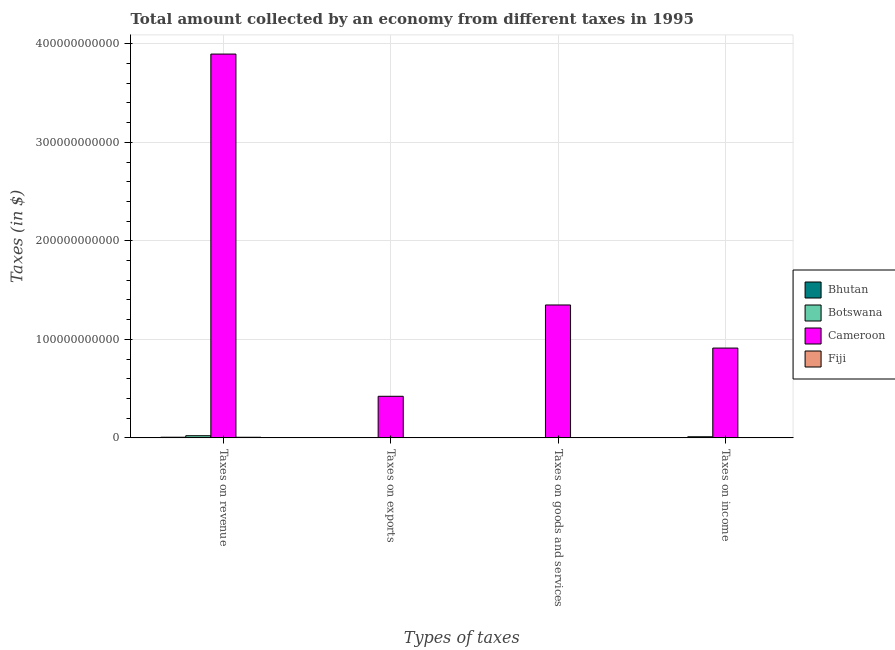How many groups of bars are there?
Give a very brief answer. 4. Are the number of bars per tick equal to the number of legend labels?
Keep it short and to the point. Yes. How many bars are there on the 3rd tick from the right?
Your answer should be very brief. 4. What is the label of the 4th group of bars from the left?
Keep it short and to the point. Taxes on income. What is the amount collected as tax on income in Bhutan?
Your response must be concise. 2.64e+08. Across all countries, what is the maximum amount collected as tax on goods?
Your answer should be compact. 1.35e+11. Across all countries, what is the minimum amount collected as tax on income?
Make the answer very short. 2.25e+08. In which country was the amount collected as tax on income maximum?
Give a very brief answer. Cameroon. In which country was the amount collected as tax on goods minimum?
Provide a short and direct response. Fiji. What is the total amount collected as tax on income in the graph?
Provide a short and direct response. 9.28e+1. What is the difference between the amount collected as tax on exports in Botswana and that in Fiji?
Make the answer very short. -1.09e+07. What is the difference between the amount collected as tax on revenue in Cameroon and the amount collected as tax on income in Bhutan?
Your response must be concise. 3.89e+11. What is the average amount collected as tax on revenue per country?
Give a very brief answer. 9.83e+1. What is the difference between the amount collected as tax on income and amount collected as tax on exports in Botswana?
Ensure brevity in your answer.  1.13e+09. In how many countries, is the amount collected as tax on income greater than 200000000000 $?
Ensure brevity in your answer.  0. What is the ratio of the amount collected as tax on exports in Bhutan to that in Cameroon?
Your answer should be very brief. 0. What is the difference between the highest and the second highest amount collected as tax on revenue?
Make the answer very short. 3.87e+11. What is the difference between the highest and the lowest amount collected as tax on exports?
Your answer should be compact. 4.22e+1. In how many countries, is the amount collected as tax on income greater than the average amount collected as tax on income taken over all countries?
Your response must be concise. 1. Is the sum of the amount collected as tax on exports in Botswana and Fiji greater than the maximum amount collected as tax on income across all countries?
Make the answer very short. No. Is it the case that in every country, the sum of the amount collected as tax on revenue and amount collected as tax on income is greater than the sum of amount collected as tax on goods and amount collected as tax on exports?
Keep it short and to the point. No. What does the 3rd bar from the left in Taxes on income represents?
Your answer should be compact. Cameroon. What does the 2nd bar from the right in Taxes on exports represents?
Your answer should be very brief. Cameroon. What is the difference between two consecutive major ticks on the Y-axis?
Offer a terse response. 1.00e+11. How many legend labels are there?
Give a very brief answer. 4. How are the legend labels stacked?
Offer a terse response. Vertical. What is the title of the graph?
Offer a very short reply. Total amount collected by an economy from different taxes in 1995. Does "Latvia" appear as one of the legend labels in the graph?
Your answer should be compact. No. What is the label or title of the X-axis?
Make the answer very short. Types of taxes. What is the label or title of the Y-axis?
Provide a succinct answer. Taxes (in $). What is the Taxes (in $) of Bhutan in Taxes on revenue?
Provide a succinct answer. 6.50e+08. What is the Taxes (in $) in Botswana in Taxes on revenue?
Provide a succinct answer. 2.20e+09. What is the Taxes (in $) of Cameroon in Taxes on revenue?
Make the answer very short. 3.90e+11. What is the Taxes (in $) in Fiji in Taxes on revenue?
Your answer should be compact. 6.15e+08. What is the Taxes (in $) in Bhutan in Taxes on exports?
Provide a short and direct response. 1.14e+07. What is the Taxes (in $) of Botswana in Taxes on exports?
Ensure brevity in your answer.  5.00e+05. What is the Taxes (in $) in Cameroon in Taxes on exports?
Provide a short and direct response. 4.22e+1. What is the Taxes (in $) of Fiji in Taxes on exports?
Give a very brief answer. 1.14e+07. What is the Taxes (in $) in Bhutan in Taxes on goods and services?
Provide a succinct answer. 3.39e+08. What is the Taxes (in $) of Botswana in Taxes on goods and services?
Provide a succinct answer. 2.38e+08. What is the Taxes (in $) in Cameroon in Taxes on goods and services?
Provide a succinct answer. 1.35e+11. What is the Taxes (in $) of Fiji in Taxes on goods and services?
Offer a terse response. 2.23e+08. What is the Taxes (in $) in Bhutan in Taxes on income?
Keep it short and to the point. 2.64e+08. What is the Taxes (in $) of Botswana in Taxes on income?
Offer a very short reply. 1.13e+09. What is the Taxes (in $) in Cameroon in Taxes on income?
Make the answer very short. 9.12e+1. What is the Taxes (in $) of Fiji in Taxes on income?
Your answer should be very brief. 2.25e+08. Across all Types of taxes, what is the maximum Taxes (in $) of Bhutan?
Keep it short and to the point. 6.50e+08. Across all Types of taxes, what is the maximum Taxes (in $) of Botswana?
Your answer should be compact. 2.20e+09. Across all Types of taxes, what is the maximum Taxes (in $) of Cameroon?
Make the answer very short. 3.90e+11. Across all Types of taxes, what is the maximum Taxes (in $) of Fiji?
Ensure brevity in your answer.  6.15e+08. Across all Types of taxes, what is the minimum Taxes (in $) in Bhutan?
Provide a short and direct response. 1.14e+07. Across all Types of taxes, what is the minimum Taxes (in $) of Botswana?
Ensure brevity in your answer.  5.00e+05. Across all Types of taxes, what is the minimum Taxes (in $) in Cameroon?
Keep it short and to the point. 4.22e+1. Across all Types of taxes, what is the minimum Taxes (in $) in Fiji?
Ensure brevity in your answer.  1.14e+07. What is the total Taxes (in $) of Bhutan in the graph?
Keep it short and to the point. 1.26e+09. What is the total Taxes (in $) of Botswana in the graph?
Your response must be concise. 3.56e+09. What is the total Taxes (in $) in Cameroon in the graph?
Make the answer very short. 6.58e+11. What is the total Taxes (in $) in Fiji in the graph?
Your answer should be compact. 1.07e+09. What is the difference between the Taxes (in $) of Bhutan in Taxes on revenue and that in Taxes on exports?
Your answer should be very brief. 6.38e+08. What is the difference between the Taxes (in $) of Botswana in Taxes on revenue and that in Taxes on exports?
Offer a very short reply. 2.20e+09. What is the difference between the Taxes (in $) in Cameroon in Taxes on revenue and that in Taxes on exports?
Make the answer very short. 3.47e+11. What is the difference between the Taxes (in $) of Fiji in Taxes on revenue and that in Taxes on exports?
Your answer should be compact. 6.04e+08. What is the difference between the Taxes (in $) in Bhutan in Taxes on revenue and that in Taxes on goods and services?
Offer a terse response. 3.11e+08. What is the difference between the Taxes (in $) in Botswana in Taxes on revenue and that in Taxes on goods and services?
Ensure brevity in your answer.  1.96e+09. What is the difference between the Taxes (in $) in Cameroon in Taxes on revenue and that in Taxes on goods and services?
Your answer should be compact. 2.55e+11. What is the difference between the Taxes (in $) of Fiji in Taxes on revenue and that in Taxes on goods and services?
Your answer should be compact. 3.93e+08. What is the difference between the Taxes (in $) in Bhutan in Taxes on revenue and that in Taxes on income?
Keep it short and to the point. 3.86e+08. What is the difference between the Taxes (in $) of Botswana in Taxes on revenue and that in Taxes on income?
Provide a short and direct response. 1.07e+09. What is the difference between the Taxes (in $) in Cameroon in Taxes on revenue and that in Taxes on income?
Ensure brevity in your answer.  2.98e+11. What is the difference between the Taxes (in $) in Fiji in Taxes on revenue and that in Taxes on income?
Provide a short and direct response. 3.90e+08. What is the difference between the Taxes (in $) in Bhutan in Taxes on exports and that in Taxes on goods and services?
Keep it short and to the point. -3.27e+08. What is the difference between the Taxes (in $) of Botswana in Taxes on exports and that in Taxes on goods and services?
Make the answer very short. -2.37e+08. What is the difference between the Taxes (in $) in Cameroon in Taxes on exports and that in Taxes on goods and services?
Offer a very short reply. -9.27e+1. What is the difference between the Taxes (in $) of Fiji in Taxes on exports and that in Taxes on goods and services?
Give a very brief answer. -2.11e+08. What is the difference between the Taxes (in $) of Bhutan in Taxes on exports and that in Taxes on income?
Offer a terse response. -2.52e+08. What is the difference between the Taxes (in $) in Botswana in Taxes on exports and that in Taxes on income?
Offer a very short reply. -1.13e+09. What is the difference between the Taxes (in $) of Cameroon in Taxes on exports and that in Taxes on income?
Ensure brevity in your answer.  -4.89e+1. What is the difference between the Taxes (in $) of Fiji in Taxes on exports and that in Taxes on income?
Offer a very short reply. -2.14e+08. What is the difference between the Taxes (in $) in Bhutan in Taxes on goods and services and that in Taxes on income?
Provide a short and direct response. 7.51e+07. What is the difference between the Taxes (in $) in Botswana in Taxes on goods and services and that in Taxes on income?
Your answer should be compact. -8.90e+08. What is the difference between the Taxes (in $) in Cameroon in Taxes on goods and services and that in Taxes on income?
Make the answer very short. 4.37e+1. What is the difference between the Taxes (in $) in Fiji in Taxes on goods and services and that in Taxes on income?
Your answer should be compact. -2.87e+06. What is the difference between the Taxes (in $) in Bhutan in Taxes on revenue and the Taxes (in $) in Botswana in Taxes on exports?
Your answer should be very brief. 6.49e+08. What is the difference between the Taxes (in $) of Bhutan in Taxes on revenue and the Taxes (in $) of Cameroon in Taxes on exports?
Make the answer very short. -4.16e+1. What is the difference between the Taxes (in $) of Bhutan in Taxes on revenue and the Taxes (in $) of Fiji in Taxes on exports?
Your response must be concise. 6.38e+08. What is the difference between the Taxes (in $) of Botswana in Taxes on revenue and the Taxes (in $) of Cameroon in Taxes on exports?
Your answer should be very brief. -4.00e+1. What is the difference between the Taxes (in $) of Botswana in Taxes on revenue and the Taxes (in $) of Fiji in Taxes on exports?
Your response must be concise. 2.19e+09. What is the difference between the Taxes (in $) of Cameroon in Taxes on revenue and the Taxes (in $) of Fiji in Taxes on exports?
Make the answer very short. 3.90e+11. What is the difference between the Taxes (in $) of Bhutan in Taxes on revenue and the Taxes (in $) of Botswana in Taxes on goods and services?
Provide a succinct answer. 4.12e+08. What is the difference between the Taxes (in $) in Bhutan in Taxes on revenue and the Taxes (in $) in Cameroon in Taxes on goods and services?
Offer a terse response. -1.34e+11. What is the difference between the Taxes (in $) of Bhutan in Taxes on revenue and the Taxes (in $) of Fiji in Taxes on goods and services?
Provide a succinct answer. 4.27e+08. What is the difference between the Taxes (in $) of Botswana in Taxes on revenue and the Taxes (in $) of Cameroon in Taxes on goods and services?
Make the answer very short. -1.33e+11. What is the difference between the Taxes (in $) in Botswana in Taxes on revenue and the Taxes (in $) in Fiji in Taxes on goods and services?
Offer a terse response. 1.98e+09. What is the difference between the Taxes (in $) of Cameroon in Taxes on revenue and the Taxes (in $) of Fiji in Taxes on goods and services?
Provide a succinct answer. 3.89e+11. What is the difference between the Taxes (in $) in Bhutan in Taxes on revenue and the Taxes (in $) in Botswana in Taxes on income?
Ensure brevity in your answer.  -4.77e+08. What is the difference between the Taxes (in $) of Bhutan in Taxes on revenue and the Taxes (in $) of Cameroon in Taxes on income?
Offer a very short reply. -9.05e+1. What is the difference between the Taxes (in $) in Bhutan in Taxes on revenue and the Taxes (in $) in Fiji in Taxes on income?
Your answer should be compact. 4.24e+08. What is the difference between the Taxes (in $) in Botswana in Taxes on revenue and the Taxes (in $) in Cameroon in Taxes on income?
Your answer should be very brief. -8.90e+1. What is the difference between the Taxes (in $) of Botswana in Taxes on revenue and the Taxes (in $) of Fiji in Taxes on income?
Give a very brief answer. 1.97e+09. What is the difference between the Taxes (in $) of Cameroon in Taxes on revenue and the Taxes (in $) of Fiji in Taxes on income?
Your answer should be compact. 3.89e+11. What is the difference between the Taxes (in $) in Bhutan in Taxes on exports and the Taxes (in $) in Botswana in Taxes on goods and services?
Provide a succinct answer. -2.26e+08. What is the difference between the Taxes (in $) in Bhutan in Taxes on exports and the Taxes (in $) in Cameroon in Taxes on goods and services?
Give a very brief answer. -1.35e+11. What is the difference between the Taxes (in $) of Bhutan in Taxes on exports and the Taxes (in $) of Fiji in Taxes on goods and services?
Your response must be concise. -2.11e+08. What is the difference between the Taxes (in $) in Botswana in Taxes on exports and the Taxes (in $) in Cameroon in Taxes on goods and services?
Keep it short and to the point. -1.35e+11. What is the difference between the Taxes (in $) in Botswana in Taxes on exports and the Taxes (in $) in Fiji in Taxes on goods and services?
Keep it short and to the point. -2.22e+08. What is the difference between the Taxes (in $) of Cameroon in Taxes on exports and the Taxes (in $) of Fiji in Taxes on goods and services?
Your response must be concise. 4.20e+1. What is the difference between the Taxes (in $) of Bhutan in Taxes on exports and the Taxes (in $) of Botswana in Taxes on income?
Provide a succinct answer. -1.12e+09. What is the difference between the Taxes (in $) of Bhutan in Taxes on exports and the Taxes (in $) of Cameroon in Taxes on income?
Your answer should be compact. -9.11e+1. What is the difference between the Taxes (in $) of Bhutan in Taxes on exports and the Taxes (in $) of Fiji in Taxes on income?
Your answer should be very brief. -2.14e+08. What is the difference between the Taxes (in $) of Botswana in Taxes on exports and the Taxes (in $) of Cameroon in Taxes on income?
Provide a short and direct response. -9.11e+1. What is the difference between the Taxes (in $) of Botswana in Taxes on exports and the Taxes (in $) of Fiji in Taxes on income?
Give a very brief answer. -2.25e+08. What is the difference between the Taxes (in $) in Cameroon in Taxes on exports and the Taxes (in $) in Fiji in Taxes on income?
Your answer should be very brief. 4.20e+1. What is the difference between the Taxes (in $) of Bhutan in Taxes on goods and services and the Taxes (in $) of Botswana in Taxes on income?
Give a very brief answer. -7.88e+08. What is the difference between the Taxes (in $) in Bhutan in Taxes on goods and services and the Taxes (in $) in Cameroon in Taxes on income?
Ensure brevity in your answer.  -9.08e+1. What is the difference between the Taxes (in $) in Bhutan in Taxes on goods and services and the Taxes (in $) in Fiji in Taxes on income?
Ensure brevity in your answer.  1.13e+08. What is the difference between the Taxes (in $) of Botswana in Taxes on goods and services and the Taxes (in $) of Cameroon in Taxes on income?
Your answer should be very brief. -9.09e+1. What is the difference between the Taxes (in $) in Botswana in Taxes on goods and services and the Taxes (in $) in Fiji in Taxes on income?
Your answer should be very brief. 1.21e+07. What is the difference between the Taxes (in $) in Cameroon in Taxes on goods and services and the Taxes (in $) in Fiji in Taxes on income?
Make the answer very short. 1.35e+11. What is the average Taxes (in $) in Bhutan per Types of taxes?
Your answer should be compact. 3.16e+08. What is the average Taxes (in $) of Botswana per Types of taxes?
Provide a short and direct response. 8.91e+08. What is the average Taxes (in $) of Cameroon per Types of taxes?
Give a very brief answer. 1.64e+11. What is the average Taxes (in $) of Fiji per Types of taxes?
Give a very brief answer. 2.69e+08. What is the difference between the Taxes (in $) in Bhutan and Taxes (in $) in Botswana in Taxes on revenue?
Keep it short and to the point. -1.55e+09. What is the difference between the Taxes (in $) in Bhutan and Taxes (in $) in Cameroon in Taxes on revenue?
Provide a short and direct response. -3.89e+11. What is the difference between the Taxes (in $) in Bhutan and Taxes (in $) in Fiji in Taxes on revenue?
Offer a very short reply. 3.45e+07. What is the difference between the Taxes (in $) of Botswana and Taxes (in $) of Cameroon in Taxes on revenue?
Give a very brief answer. -3.87e+11. What is the difference between the Taxes (in $) of Botswana and Taxes (in $) of Fiji in Taxes on revenue?
Your answer should be very brief. 1.58e+09. What is the difference between the Taxes (in $) in Cameroon and Taxes (in $) in Fiji in Taxes on revenue?
Offer a very short reply. 3.89e+11. What is the difference between the Taxes (in $) of Bhutan and Taxes (in $) of Botswana in Taxes on exports?
Offer a terse response. 1.09e+07. What is the difference between the Taxes (in $) in Bhutan and Taxes (in $) in Cameroon in Taxes on exports?
Provide a succinct answer. -4.22e+1. What is the difference between the Taxes (in $) in Bhutan and Taxes (in $) in Fiji in Taxes on exports?
Offer a terse response. 2.00e+04. What is the difference between the Taxes (in $) of Botswana and Taxes (in $) of Cameroon in Taxes on exports?
Give a very brief answer. -4.22e+1. What is the difference between the Taxes (in $) of Botswana and Taxes (in $) of Fiji in Taxes on exports?
Keep it short and to the point. -1.09e+07. What is the difference between the Taxes (in $) of Cameroon and Taxes (in $) of Fiji in Taxes on exports?
Keep it short and to the point. 4.22e+1. What is the difference between the Taxes (in $) of Bhutan and Taxes (in $) of Botswana in Taxes on goods and services?
Your response must be concise. 1.01e+08. What is the difference between the Taxes (in $) of Bhutan and Taxes (in $) of Cameroon in Taxes on goods and services?
Offer a very short reply. -1.35e+11. What is the difference between the Taxes (in $) of Bhutan and Taxes (in $) of Fiji in Taxes on goods and services?
Provide a short and direct response. 1.16e+08. What is the difference between the Taxes (in $) in Botswana and Taxes (in $) in Cameroon in Taxes on goods and services?
Make the answer very short. -1.35e+11. What is the difference between the Taxes (in $) in Botswana and Taxes (in $) in Fiji in Taxes on goods and services?
Offer a terse response. 1.50e+07. What is the difference between the Taxes (in $) of Cameroon and Taxes (in $) of Fiji in Taxes on goods and services?
Ensure brevity in your answer.  1.35e+11. What is the difference between the Taxes (in $) in Bhutan and Taxes (in $) in Botswana in Taxes on income?
Offer a terse response. -8.64e+08. What is the difference between the Taxes (in $) of Bhutan and Taxes (in $) of Cameroon in Taxes on income?
Your response must be concise. -9.09e+1. What is the difference between the Taxes (in $) of Bhutan and Taxes (in $) of Fiji in Taxes on income?
Ensure brevity in your answer.  3.80e+07. What is the difference between the Taxes (in $) in Botswana and Taxes (in $) in Cameroon in Taxes on income?
Make the answer very short. -9.00e+1. What is the difference between the Taxes (in $) in Botswana and Taxes (in $) in Fiji in Taxes on income?
Your answer should be compact. 9.02e+08. What is the difference between the Taxes (in $) of Cameroon and Taxes (in $) of Fiji in Taxes on income?
Your answer should be compact. 9.09e+1. What is the ratio of the Taxes (in $) of Botswana in Taxes on revenue to that in Taxes on exports?
Your answer should be very brief. 4397.4. What is the ratio of the Taxes (in $) in Cameroon in Taxes on revenue to that in Taxes on exports?
Provide a short and direct response. 9.23. What is the ratio of the Taxes (in $) in Fiji in Taxes on revenue to that in Taxes on exports?
Give a very brief answer. 54.07. What is the ratio of the Taxes (in $) of Bhutan in Taxes on revenue to that in Taxes on goods and services?
Keep it short and to the point. 1.92. What is the ratio of the Taxes (in $) of Botswana in Taxes on revenue to that in Taxes on goods and services?
Ensure brevity in your answer.  9.25. What is the ratio of the Taxes (in $) of Cameroon in Taxes on revenue to that in Taxes on goods and services?
Offer a very short reply. 2.89. What is the ratio of the Taxes (in $) in Fiji in Taxes on revenue to that in Taxes on goods and services?
Your response must be concise. 2.76. What is the ratio of the Taxes (in $) in Bhutan in Taxes on revenue to that in Taxes on income?
Keep it short and to the point. 2.47. What is the ratio of the Taxes (in $) in Botswana in Taxes on revenue to that in Taxes on income?
Make the answer very short. 1.95. What is the ratio of the Taxes (in $) of Cameroon in Taxes on revenue to that in Taxes on income?
Offer a very short reply. 4.27. What is the ratio of the Taxes (in $) in Fiji in Taxes on revenue to that in Taxes on income?
Provide a short and direct response. 2.73. What is the ratio of the Taxes (in $) in Bhutan in Taxes on exports to that in Taxes on goods and services?
Make the answer very short. 0.03. What is the ratio of the Taxes (in $) in Botswana in Taxes on exports to that in Taxes on goods and services?
Offer a very short reply. 0. What is the ratio of the Taxes (in $) in Cameroon in Taxes on exports to that in Taxes on goods and services?
Offer a terse response. 0.31. What is the ratio of the Taxes (in $) in Fiji in Taxes on exports to that in Taxes on goods and services?
Provide a succinct answer. 0.05. What is the ratio of the Taxes (in $) of Bhutan in Taxes on exports to that in Taxes on income?
Your response must be concise. 0.04. What is the ratio of the Taxes (in $) in Cameroon in Taxes on exports to that in Taxes on income?
Give a very brief answer. 0.46. What is the ratio of the Taxes (in $) of Fiji in Taxes on exports to that in Taxes on income?
Make the answer very short. 0.05. What is the ratio of the Taxes (in $) of Bhutan in Taxes on goods and services to that in Taxes on income?
Offer a very short reply. 1.28. What is the ratio of the Taxes (in $) in Botswana in Taxes on goods and services to that in Taxes on income?
Your answer should be compact. 0.21. What is the ratio of the Taxes (in $) in Cameroon in Taxes on goods and services to that in Taxes on income?
Offer a terse response. 1.48. What is the ratio of the Taxes (in $) in Fiji in Taxes on goods and services to that in Taxes on income?
Your response must be concise. 0.99. What is the difference between the highest and the second highest Taxes (in $) of Bhutan?
Your response must be concise. 3.11e+08. What is the difference between the highest and the second highest Taxes (in $) of Botswana?
Your response must be concise. 1.07e+09. What is the difference between the highest and the second highest Taxes (in $) in Cameroon?
Provide a succinct answer. 2.55e+11. What is the difference between the highest and the second highest Taxes (in $) in Fiji?
Provide a succinct answer. 3.90e+08. What is the difference between the highest and the lowest Taxes (in $) in Bhutan?
Your response must be concise. 6.38e+08. What is the difference between the highest and the lowest Taxes (in $) of Botswana?
Make the answer very short. 2.20e+09. What is the difference between the highest and the lowest Taxes (in $) in Cameroon?
Provide a succinct answer. 3.47e+11. What is the difference between the highest and the lowest Taxes (in $) in Fiji?
Your response must be concise. 6.04e+08. 